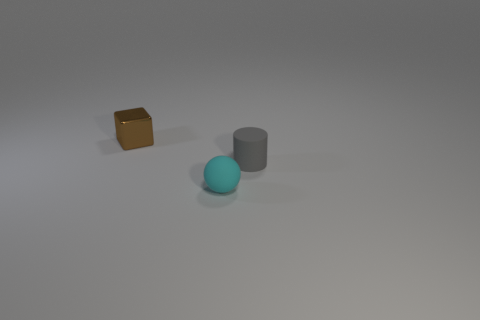Add 1 tiny purple matte things. How many objects exist? 4 Subtract all balls. How many objects are left? 2 Add 1 large yellow matte things. How many large yellow matte things exist? 1 Subtract 0 gray blocks. How many objects are left? 3 Subtract 1 cylinders. How many cylinders are left? 0 Subtract all green balls. Subtract all purple cylinders. How many balls are left? 1 Subtract all gray cylinders. Subtract all small gray cylinders. How many objects are left? 1 Add 1 rubber balls. How many rubber balls are left? 2 